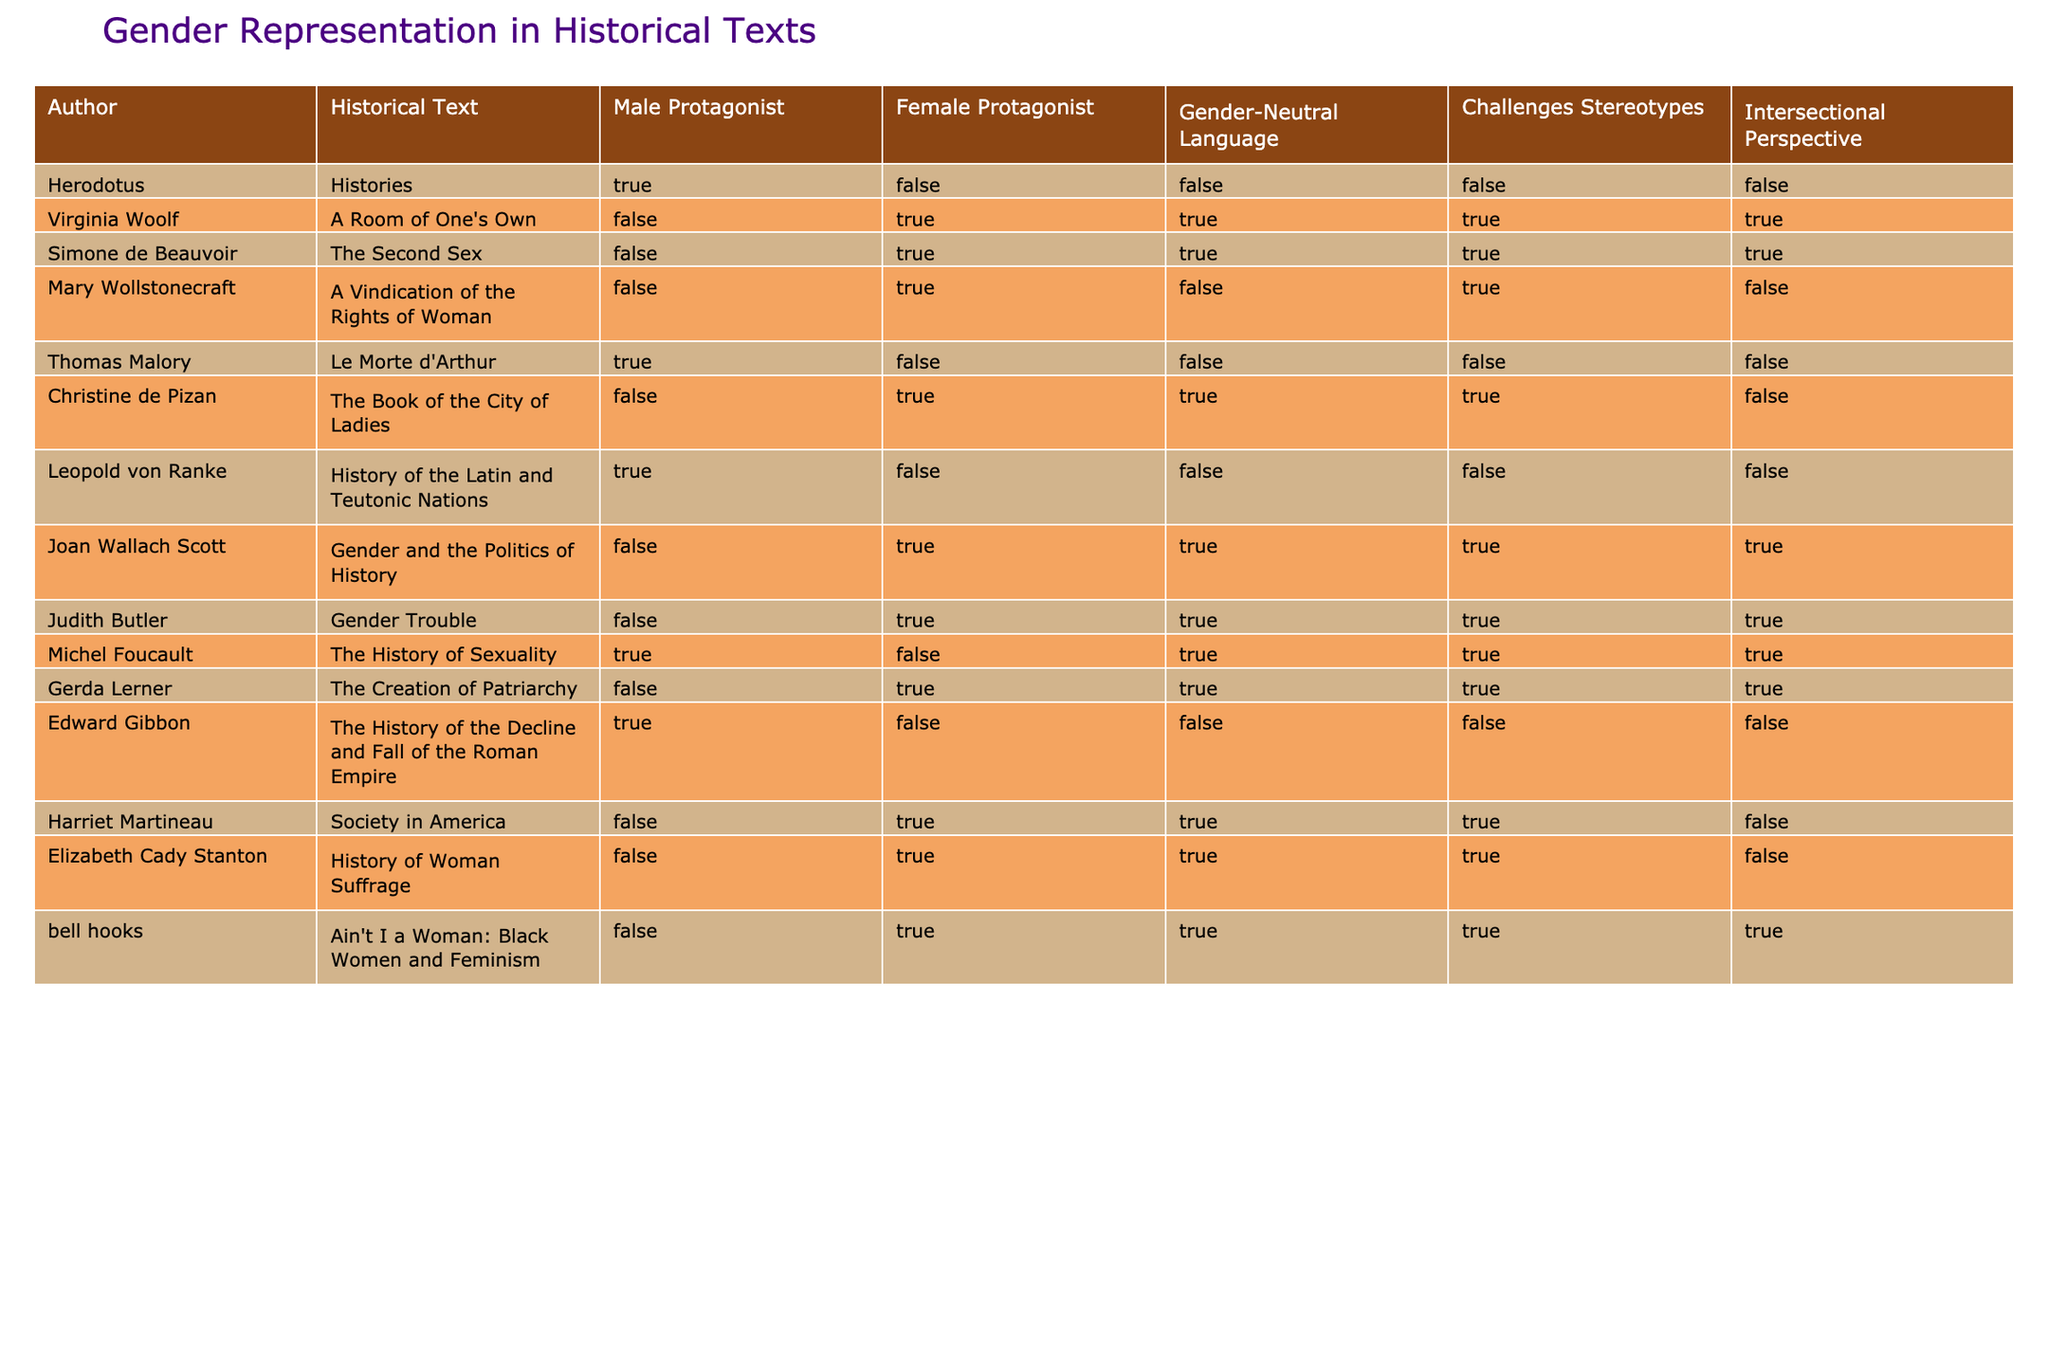What is the title of the historical text by Virginia Woolf? The title of the historical text by Virginia Woolf is presented in the second column of the table, which specifically states "A Room of One's Own."
Answer: A Room of One's Own How many authors in the list feature female protagonists? To find the number of authors featuring female protagonists, we can filter the table where the column "Female Protagonist" is true. The names meeting this criterion can be found in the rows for Virginia Woolf, Simone de Beauvoir, Mary Wollstonecraft, Christine de Pizan, Joan Wallach Scott, Judith Butler, Gerda Lerner, Harriet Martineau, Elizabeth Cady Stanton, and bell hooks. This results in a total count of ten.
Answer: 10 Is Michel Foucault's historical text written with gender-neutral language? Looking at the column "Gender-Neutral Language," we see that it indicates true for Michel Foucault's text, as it is clearly marked as true in the table.
Answer: Yes Which author has a historical text that challenges stereotypes and provides an intersectional perspective? In the table, we examine the columns for "Challenges Stereotypes" and "Intersectional Perspective." Judith Butler and bell hooks are two authors whose texts are marked as true for both of these criteria, indicating they meet the conditions of challenging stereotypes while having an intersectional perspective.
Answer: Judith Butler and bell hooks What percentage of the historical texts listed utilize male protagonists? We're looking at the first column, where the "Male Protagonist" indicates true for Herodotus, Thomas Malory, Leopold von Ranke, and Edward Gibbon, showing that 4 out of 15 authors (a total of 15 historical texts) feature male protagonists. Therefore, the percentage is calculated as (4/15)*100, which results in approximately 26.67%.
Answer: 26.67% 